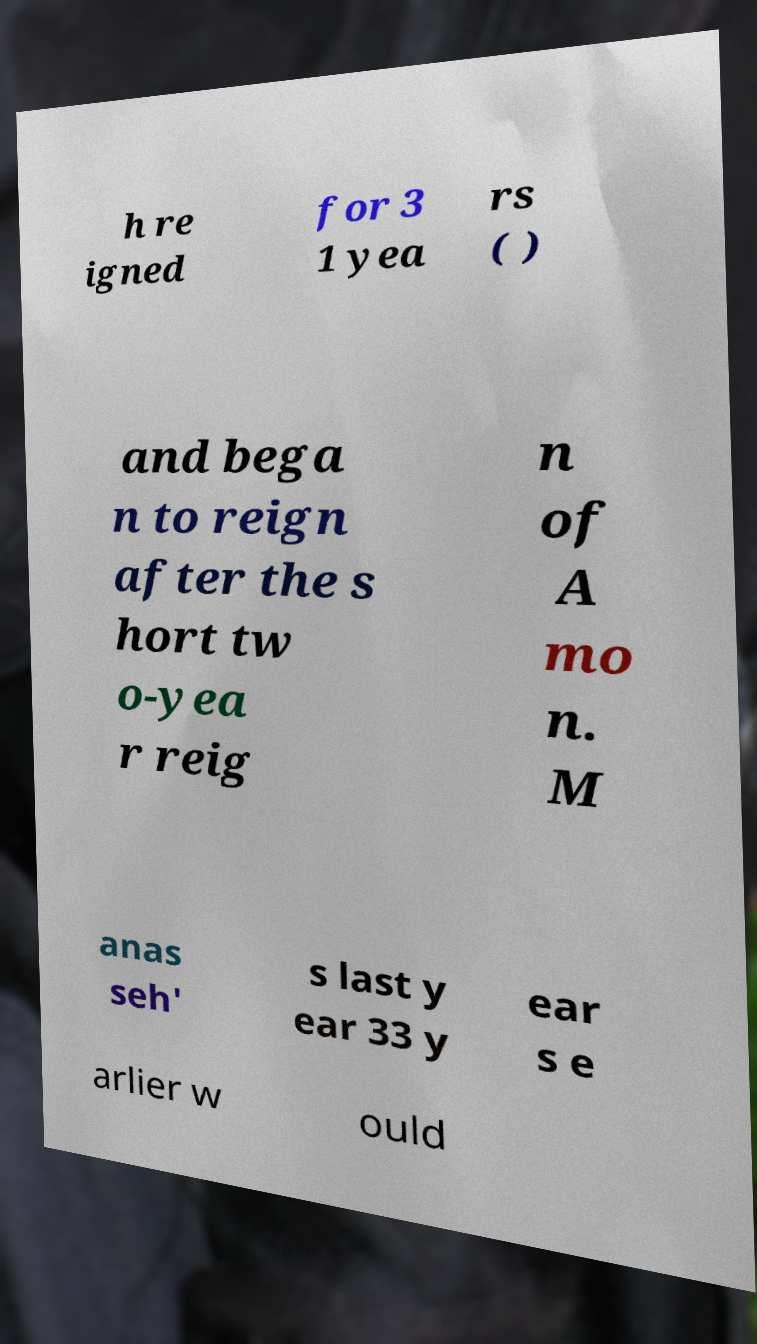What messages or text are displayed in this image? I need them in a readable, typed format. h re igned for 3 1 yea rs ( ) and bega n to reign after the s hort tw o-yea r reig n of A mo n. M anas seh' s last y ear 33 y ear s e arlier w ould 